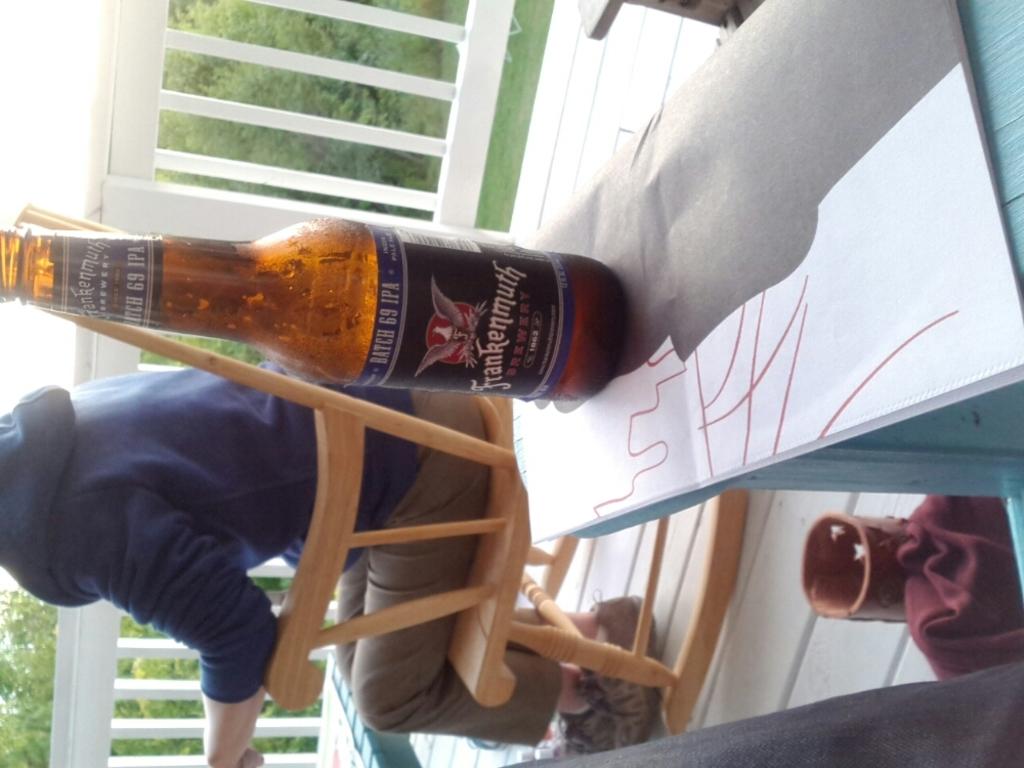What batch number is this ipa from?
Provide a succinct answer. 69. 